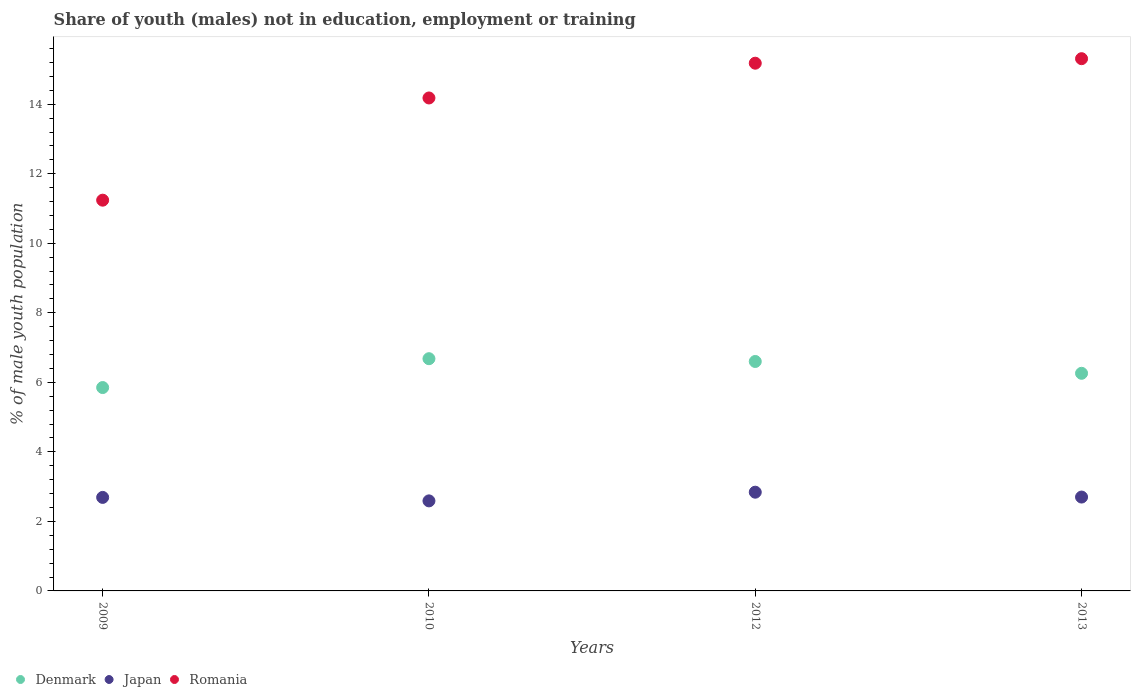What is the percentage of unemployed males population in in Japan in 2010?
Ensure brevity in your answer.  2.59. Across all years, what is the maximum percentage of unemployed males population in in Romania?
Your response must be concise. 15.31. Across all years, what is the minimum percentage of unemployed males population in in Romania?
Ensure brevity in your answer.  11.24. What is the total percentage of unemployed males population in in Denmark in the graph?
Keep it short and to the point. 25.39. What is the difference between the percentage of unemployed males population in in Denmark in 2013 and the percentage of unemployed males population in in Japan in 2009?
Give a very brief answer. 3.57. What is the average percentage of unemployed males population in in Denmark per year?
Make the answer very short. 6.35. In the year 2009, what is the difference between the percentage of unemployed males population in in Japan and percentage of unemployed males population in in Denmark?
Offer a terse response. -3.16. What is the ratio of the percentage of unemployed males population in in Romania in 2010 to that in 2012?
Ensure brevity in your answer.  0.93. What is the difference between the highest and the second highest percentage of unemployed males population in in Denmark?
Provide a short and direct response. 0.08. What is the difference between the highest and the lowest percentage of unemployed males population in in Romania?
Your response must be concise. 4.07. In how many years, is the percentage of unemployed males population in in Denmark greater than the average percentage of unemployed males population in in Denmark taken over all years?
Ensure brevity in your answer.  2. Is the sum of the percentage of unemployed males population in in Denmark in 2012 and 2013 greater than the maximum percentage of unemployed males population in in Romania across all years?
Provide a succinct answer. No. Is it the case that in every year, the sum of the percentage of unemployed males population in in Denmark and percentage of unemployed males population in in Japan  is greater than the percentage of unemployed males population in in Romania?
Provide a succinct answer. No. Is the percentage of unemployed males population in in Denmark strictly less than the percentage of unemployed males population in in Romania over the years?
Offer a very short reply. Yes. How many years are there in the graph?
Make the answer very short. 4. Does the graph contain any zero values?
Provide a short and direct response. No. How many legend labels are there?
Offer a terse response. 3. How are the legend labels stacked?
Your answer should be very brief. Horizontal. What is the title of the graph?
Offer a terse response. Share of youth (males) not in education, employment or training. Does "Comoros" appear as one of the legend labels in the graph?
Your answer should be compact. No. What is the label or title of the Y-axis?
Offer a very short reply. % of male youth population. What is the % of male youth population in Denmark in 2009?
Keep it short and to the point. 5.85. What is the % of male youth population of Japan in 2009?
Ensure brevity in your answer.  2.69. What is the % of male youth population of Romania in 2009?
Keep it short and to the point. 11.24. What is the % of male youth population of Denmark in 2010?
Make the answer very short. 6.68. What is the % of male youth population of Japan in 2010?
Make the answer very short. 2.59. What is the % of male youth population of Romania in 2010?
Provide a succinct answer. 14.18. What is the % of male youth population of Denmark in 2012?
Your answer should be compact. 6.6. What is the % of male youth population of Japan in 2012?
Provide a succinct answer. 2.84. What is the % of male youth population in Romania in 2012?
Keep it short and to the point. 15.18. What is the % of male youth population in Denmark in 2013?
Your answer should be very brief. 6.26. What is the % of male youth population in Japan in 2013?
Offer a terse response. 2.7. What is the % of male youth population in Romania in 2013?
Keep it short and to the point. 15.31. Across all years, what is the maximum % of male youth population in Denmark?
Ensure brevity in your answer.  6.68. Across all years, what is the maximum % of male youth population in Japan?
Provide a short and direct response. 2.84. Across all years, what is the maximum % of male youth population of Romania?
Make the answer very short. 15.31. Across all years, what is the minimum % of male youth population in Denmark?
Make the answer very short. 5.85. Across all years, what is the minimum % of male youth population in Japan?
Your response must be concise. 2.59. Across all years, what is the minimum % of male youth population of Romania?
Offer a very short reply. 11.24. What is the total % of male youth population of Denmark in the graph?
Offer a very short reply. 25.39. What is the total % of male youth population in Japan in the graph?
Provide a short and direct response. 10.82. What is the total % of male youth population of Romania in the graph?
Your response must be concise. 55.91. What is the difference between the % of male youth population of Denmark in 2009 and that in 2010?
Offer a terse response. -0.83. What is the difference between the % of male youth population of Japan in 2009 and that in 2010?
Make the answer very short. 0.1. What is the difference between the % of male youth population of Romania in 2009 and that in 2010?
Offer a very short reply. -2.94. What is the difference between the % of male youth population in Denmark in 2009 and that in 2012?
Your response must be concise. -0.75. What is the difference between the % of male youth population of Japan in 2009 and that in 2012?
Give a very brief answer. -0.15. What is the difference between the % of male youth population in Romania in 2009 and that in 2012?
Provide a short and direct response. -3.94. What is the difference between the % of male youth population of Denmark in 2009 and that in 2013?
Your response must be concise. -0.41. What is the difference between the % of male youth population in Japan in 2009 and that in 2013?
Make the answer very short. -0.01. What is the difference between the % of male youth population of Romania in 2009 and that in 2013?
Ensure brevity in your answer.  -4.07. What is the difference between the % of male youth population of Romania in 2010 and that in 2012?
Give a very brief answer. -1. What is the difference between the % of male youth population in Denmark in 2010 and that in 2013?
Your response must be concise. 0.42. What is the difference between the % of male youth population in Japan in 2010 and that in 2013?
Provide a short and direct response. -0.11. What is the difference between the % of male youth population in Romania in 2010 and that in 2013?
Give a very brief answer. -1.13. What is the difference between the % of male youth population in Denmark in 2012 and that in 2013?
Make the answer very short. 0.34. What is the difference between the % of male youth population in Japan in 2012 and that in 2013?
Provide a short and direct response. 0.14. What is the difference between the % of male youth population in Romania in 2012 and that in 2013?
Provide a succinct answer. -0.13. What is the difference between the % of male youth population of Denmark in 2009 and the % of male youth population of Japan in 2010?
Make the answer very short. 3.26. What is the difference between the % of male youth population of Denmark in 2009 and the % of male youth population of Romania in 2010?
Your answer should be compact. -8.33. What is the difference between the % of male youth population of Japan in 2009 and the % of male youth population of Romania in 2010?
Offer a very short reply. -11.49. What is the difference between the % of male youth population of Denmark in 2009 and the % of male youth population of Japan in 2012?
Offer a terse response. 3.01. What is the difference between the % of male youth population in Denmark in 2009 and the % of male youth population in Romania in 2012?
Make the answer very short. -9.33. What is the difference between the % of male youth population in Japan in 2009 and the % of male youth population in Romania in 2012?
Your answer should be very brief. -12.49. What is the difference between the % of male youth population in Denmark in 2009 and the % of male youth population in Japan in 2013?
Your answer should be compact. 3.15. What is the difference between the % of male youth population in Denmark in 2009 and the % of male youth population in Romania in 2013?
Your response must be concise. -9.46. What is the difference between the % of male youth population of Japan in 2009 and the % of male youth population of Romania in 2013?
Give a very brief answer. -12.62. What is the difference between the % of male youth population of Denmark in 2010 and the % of male youth population of Japan in 2012?
Keep it short and to the point. 3.84. What is the difference between the % of male youth population of Denmark in 2010 and the % of male youth population of Romania in 2012?
Your answer should be compact. -8.5. What is the difference between the % of male youth population in Japan in 2010 and the % of male youth population in Romania in 2012?
Ensure brevity in your answer.  -12.59. What is the difference between the % of male youth population of Denmark in 2010 and the % of male youth population of Japan in 2013?
Provide a short and direct response. 3.98. What is the difference between the % of male youth population of Denmark in 2010 and the % of male youth population of Romania in 2013?
Make the answer very short. -8.63. What is the difference between the % of male youth population of Japan in 2010 and the % of male youth population of Romania in 2013?
Offer a very short reply. -12.72. What is the difference between the % of male youth population in Denmark in 2012 and the % of male youth population in Romania in 2013?
Offer a terse response. -8.71. What is the difference between the % of male youth population in Japan in 2012 and the % of male youth population in Romania in 2013?
Keep it short and to the point. -12.47. What is the average % of male youth population in Denmark per year?
Ensure brevity in your answer.  6.35. What is the average % of male youth population in Japan per year?
Provide a succinct answer. 2.71. What is the average % of male youth population in Romania per year?
Ensure brevity in your answer.  13.98. In the year 2009, what is the difference between the % of male youth population of Denmark and % of male youth population of Japan?
Provide a succinct answer. 3.16. In the year 2009, what is the difference between the % of male youth population of Denmark and % of male youth population of Romania?
Keep it short and to the point. -5.39. In the year 2009, what is the difference between the % of male youth population in Japan and % of male youth population in Romania?
Your answer should be compact. -8.55. In the year 2010, what is the difference between the % of male youth population of Denmark and % of male youth population of Japan?
Your answer should be compact. 4.09. In the year 2010, what is the difference between the % of male youth population of Denmark and % of male youth population of Romania?
Keep it short and to the point. -7.5. In the year 2010, what is the difference between the % of male youth population in Japan and % of male youth population in Romania?
Make the answer very short. -11.59. In the year 2012, what is the difference between the % of male youth population of Denmark and % of male youth population of Japan?
Offer a terse response. 3.76. In the year 2012, what is the difference between the % of male youth population in Denmark and % of male youth population in Romania?
Your response must be concise. -8.58. In the year 2012, what is the difference between the % of male youth population of Japan and % of male youth population of Romania?
Your answer should be compact. -12.34. In the year 2013, what is the difference between the % of male youth population in Denmark and % of male youth population in Japan?
Give a very brief answer. 3.56. In the year 2013, what is the difference between the % of male youth population of Denmark and % of male youth population of Romania?
Offer a terse response. -9.05. In the year 2013, what is the difference between the % of male youth population in Japan and % of male youth population in Romania?
Your answer should be compact. -12.61. What is the ratio of the % of male youth population in Denmark in 2009 to that in 2010?
Provide a short and direct response. 0.88. What is the ratio of the % of male youth population in Japan in 2009 to that in 2010?
Offer a terse response. 1.04. What is the ratio of the % of male youth population of Romania in 2009 to that in 2010?
Make the answer very short. 0.79. What is the ratio of the % of male youth population of Denmark in 2009 to that in 2012?
Provide a short and direct response. 0.89. What is the ratio of the % of male youth population of Japan in 2009 to that in 2012?
Ensure brevity in your answer.  0.95. What is the ratio of the % of male youth population in Romania in 2009 to that in 2012?
Your response must be concise. 0.74. What is the ratio of the % of male youth population of Denmark in 2009 to that in 2013?
Keep it short and to the point. 0.93. What is the ratio of the % of male youth population of Japan in 2009 to that in 2013?
Provide a short and direct response. 1. What is the ratio of the % of male youth population in Romania in 2009 to that in 2013?
Your answer should be very brief. 0.73. What is the ratio of the % of male youth population of Denmark in 2010 to that in 2012?
Provide a short and direct response. 1.01. What is the ratio of the % of male youth population of Japan in 2010 to that in 2012?
Make the answer very short. 0.91. What is the ratio of the % of male youth population in Romania in 2010 to that in 2012?
Offer a very short reply. 0.93. What is the ratio of the % of male youth population in Denmark in 2010 to that in 2013?
Your answer should be compact. 1.07. What is the ratio of the % of male youth population in Japan in 2010 to that in 2013?
Offer a very short reply. 0.96. What is the ratio of the % of male youth population in Romania in 2010 to that in 2013?
Give a very brief answer. 0.93. What is the ratio of the % of male youth population of Denmark in 2012 to that in 2013?
Your answer should be compact. 1.05. What is the ratio of the % of male youth population in Japan in 2012 to that in 2013?
Your response must be concise. 1.05. What is the difference between the highest and the second highest % of male youth population of Japan?
Your answer should be compact. 0.14. What is the difference between the highest and the second highest % of male youth population in Romania?
Your answer should be very brief. 0.13. What is the difference between the highest and the lowest % of male youth population of Denmark?
Your answer should be compact. 0.83. What is the difference between the highest and the lowest % of male youth population in Japan?
Keep it short and to the point. 0.25. What is the difference between the highest and the lowest % of male youth population of Romania?
Provide a succinct answer. 4.07. 